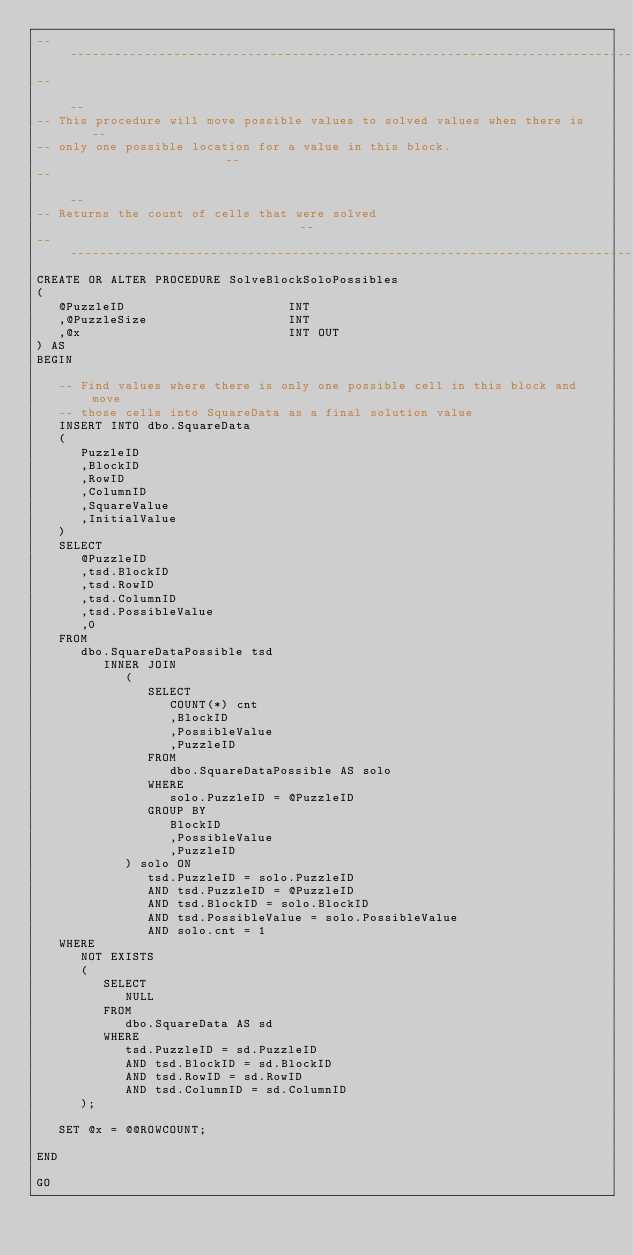<code> <loc_0><loc_0><loc_500><loc_500><_SQL_>--------------------------------------------------------------------------------
--                                                                            --
-- This procedure will move possible values to solved values when there is    --
-- only one possible location for a value in this block.                      --
--                                                                            --
-- Returns the count of cells that were solved                                --
--------------------------------------------------------------------------------
CREATE OR ALTER PROCEDURE SolveBlockSoloPossibles
(
   @PuzzleID                      INT
   ,@PuzzleSize                   INT
   ,@x                            INT OUT
) AS
BEGIN

   -- Find values where there is only one possible cell in this block and move 
   -- those cells into SquareData as a final solution value
   INSERT INTO dbo.SquareData
   (
      PuzzleID
      ,BlockID
      ,RowID
      ,ColumnID
      ,SquareValue
      ,InitialValue
   )
   SELECT
      @PuzzleID
      ,tsd.BlockID
      ,tsd.RowID
      ,tsd.ColumnID
      ,tsd.PossibleValue
      ,0
   FROM
      dbo.SquareDataPossible tsd
         INNER JOIN
            (
               SELECT
                  COUNT(*) cnt
                  ,BlockID
                  ,PossibleValue
                  ,PuzzleID
               FROM
                  dbo.SquareDataPossible AS solo
               WHERE
                  solo.PuzzleID = @PuzzleID
               GROUP BY
                  BlockID
                  ,PossibleValue
                  ,PuzzleID
            ) solo ON
               tsd.PuzzleID = solo.PuzzleID
               AND tsd.PuzzleID = @PuzzleID
               AND tsd.BlockID = solo.BlockID
               AND tsd.PossibleValue = solo.PossibleValue
               AND solo.cnt = 1
   WHERE
      NOT EXISTS
      (
         SELECT
            NULL
         FROM
            dbo.SquareData AS sd
         WHERE
            tsd.PuzzleID = sd.PuzzleID
            AND tsd.BlockID = sd.BlockID
            AND tsd.RowID = sd.RowID
            AND tsd.ColumnID = sd.ColumnID
      );
   
   SET @x = @@ROWCOUNT;

END

GO
</code> 